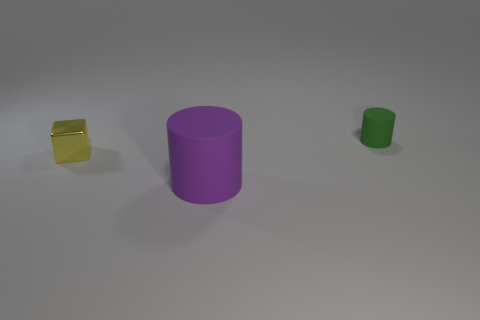Add 2 yellow metal objects. How many objects exist? 5 Subtract all cylinders. How many objects are left? 1 Subtract 1 purple cylinders. How many objects are left? 2 Subtract all tiny yellow shiny blocks. Subtract all cubes. How many objects are left? 1 Add 3 yellow blocks. How many yellow blocks are left? 4 Add 2 tiny yellow blocks. How many tiny yellow blocks exist? 3 